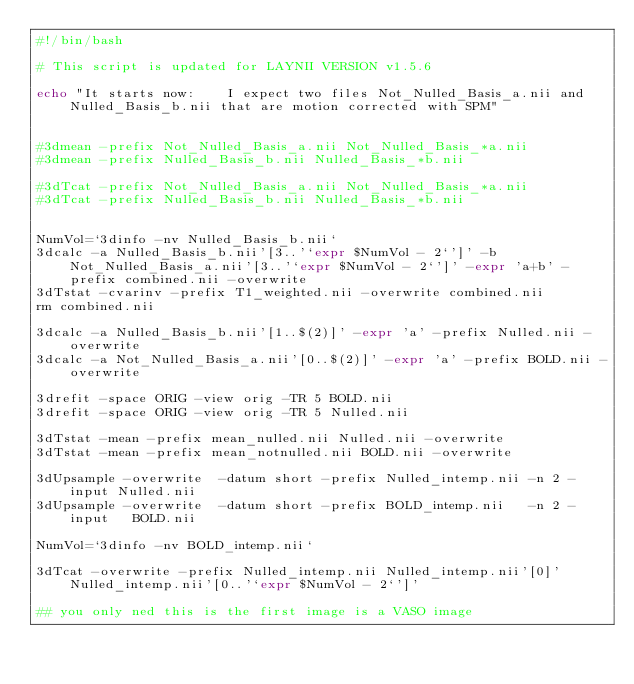<code> <loc_0><loc_0><loc_500><loc_500><_Bash_>#!/bin/bash

# This script is updated for LAYNII VERSION v1.5.6

echo "It starts now:    I expect two files Not_Nulled_Basis_a.nii and Nulled_Basis_b.nii that are motion corrected with SPM"


#3dmean -prefix Not_Nulled_Basis_a.nii Not_Nulled_Basis_*a.nii 
#3dmean -prefix Nulled_Basis_b.nii Nulled_Basis_*b.nii

#3dTcat -prefix Not_Nulled_Basis_a.nii Not_Nulled_Basis_*a.nii 
#3dTcat -prefix Nulled_Basis_b.nii Nulled_Basis_*b.nii


NumVol=`3dinfo -nv Nulled_Basis_b.nii`
3dcalc -a Nulled_Basis_b.nii'[3..'`expr $NumVol - 2`']' -b  Not_Nulled_Basis_a.nii'[3..'`expr $NumVol - 2`']' -expr 'a+b' -prefix combined.nii -overwrite
3dTstat -cvarinv -prefix T1_weighted.nii -overwrite combined.nii 
rm combined.nii

3dcalc -a Nulled_Basis_b.nii'[1..$(2)]' -expr 'a' -prefix Nulled.nii -overwrite
3dcalc -a Not_Nulled_Basis_a.nii'[0..$(2)]' -expr 'a' -prefix BOLD.nii -overwrite

3drefit -space ORIG -view orig -TR 5 BOLD.nii
3drefit -space ORIG -view orig -TR 5 Nulled.nii

3dTstat -mean -prefix mean_nulled.nii Nulled.nii -overwrite
3dTstat -mean -prefix mean_notnulled.nii BOLD.nii -overwrite

3dUpsample -overwrite  -datum short -prefix Nulled_intemp.nii -n 2 -input Nulled.nii
3dUpsample -overwrite  -datum short -prefix BOLD_intemp.nii   -n 2 -input   BOLD.nii

NumVol=`3dinfo -nv BOLD_intemp.nii`

3dTcat -overwrite -prefix Nulled_intemp.nii Nulled_intemp.nii'[0]' Nulled_intemp.nii'[0..'`expr $NumVol - 2`']' 

## you only ned this is the first image is a VASO image</code> 